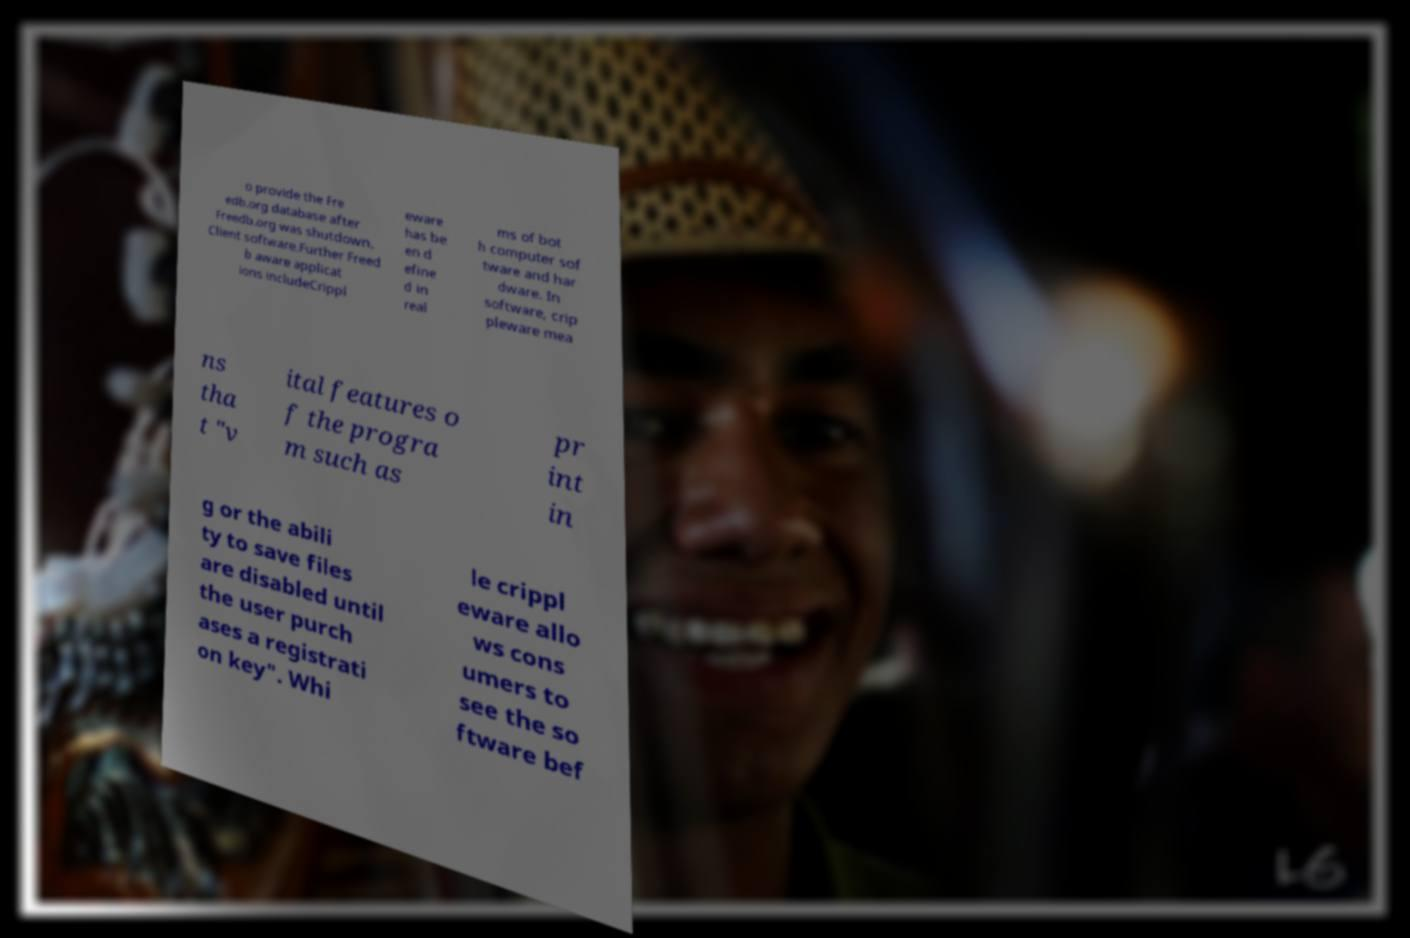Could you assist in decoding the text presented in this image and type it out clearly? o provide the Fre edb.org database after Freedb.org was shutdown. Client software.Further Freed b aware applicat ions includeCrippl eware has be en d efine d in real ms of bot h computer sof tware and har dware. In software, crip pleware mea ns tha t "v ital features o f the progra m such as pr int in g or the abili ty to save files are disabled until the user purch ases a registrati on key". Whi le crippl eware allo ws cons umers to see the so ftware bef 